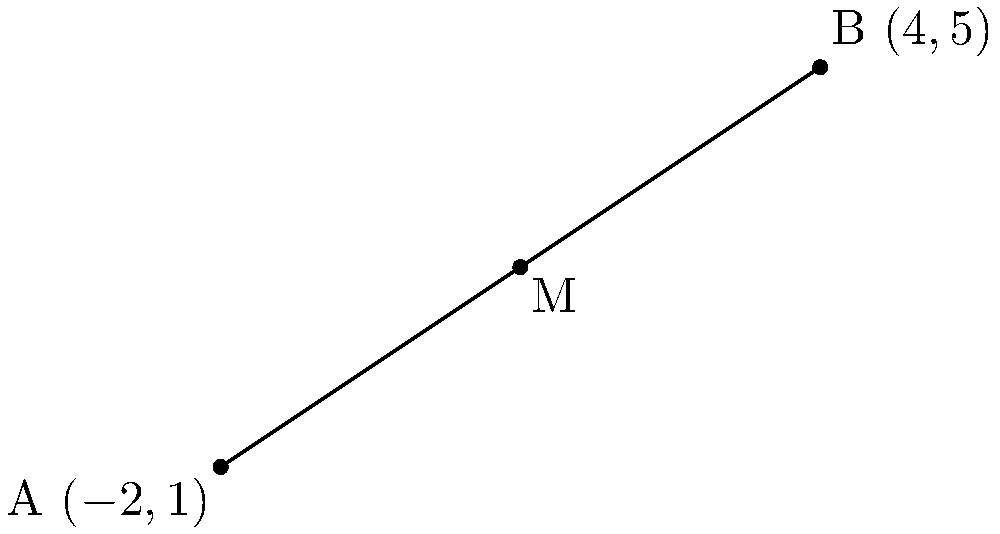As an aspiring interviewer, you're preparing questions about coordinate geometry. Consider the line segment AB shown in the graph, where A is at $(-2,1)$ and B is at $(4,5)$. What are the coordinates of the midpoint M of this line segment? To find the midpoint of a line segment, we can use the midpoint formula:

$M = (\frac{x_1 + x_2}{2}, \frac{y_1 + y_2}{2})$

Where $(x_1, y_1)$ are the coordinates of point A and $(x_2, y_2)$ are the coordinates of point B.

Given:
A $(-2, 1)$, so $x_1 = -2$ and $y_1 = 1$
B $(4, 5)$, so $x_2 = 4$ and $y_2 = 5$

Step 1: Calculate the x-coordinate of the midpoint:
$x_M = \frac{x_1 + x_2}{2} = \frac{-2 + 4}{2} = \frac{2}{2} = 1$

Step 2: Calculate the y-coordinate of the midpoint:
$y_M = \frac{y_1 + y_2}{2} = \frac{1 + 5}{2} = \frac{6}{2} = 3$

Therefore, the coordinates of the midpoint M are $(1, 3)$.
Answer: $(1, 3)$ 